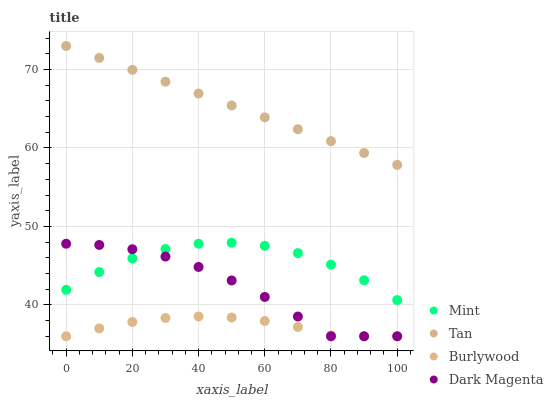Does Burlywood have the minimum area under the curve?
Answer yes or no. Yes. Does Tan have the maximum area under the curve?
Answer yes or no. Yes. Does Mint have the minimum area under the curve?
Answer yes or no. No. Does Mint have the maximum area under the curve?
Answer yes or no. No. Is Tan the smoothest?
Answer yes or no. Yes. Is Dark Magenta the roughest?
Answer yes or no. Yes. Is Mint the smoothest?
Answer yes or no. No. Is Mint the roughest?
Answer yes or no. No. Does Burlywood have the lowest value?
Answer yes or no. Yes. Does Mint have the lowest value?
Answer yes or no. No. Does Tan have the highest value?
Answer yes or no. Yes. Does Mint have the highest value?
Answer yes or no. No. Is Mint less than Tan?
Answer yes or no. Yes. Is Tan greater than Dark Magenta?
Answer yes or no. Yes. Does Mint intersect Dark Magenta?
Answer yes or no. Yes. Is Mint less than Dark Magenta?
Answer yes or no. No. Is Mint greater than Dark Magenta?
Answer yes or no. No. Does Mint intersect Tan?
Answer yes or no. No. 